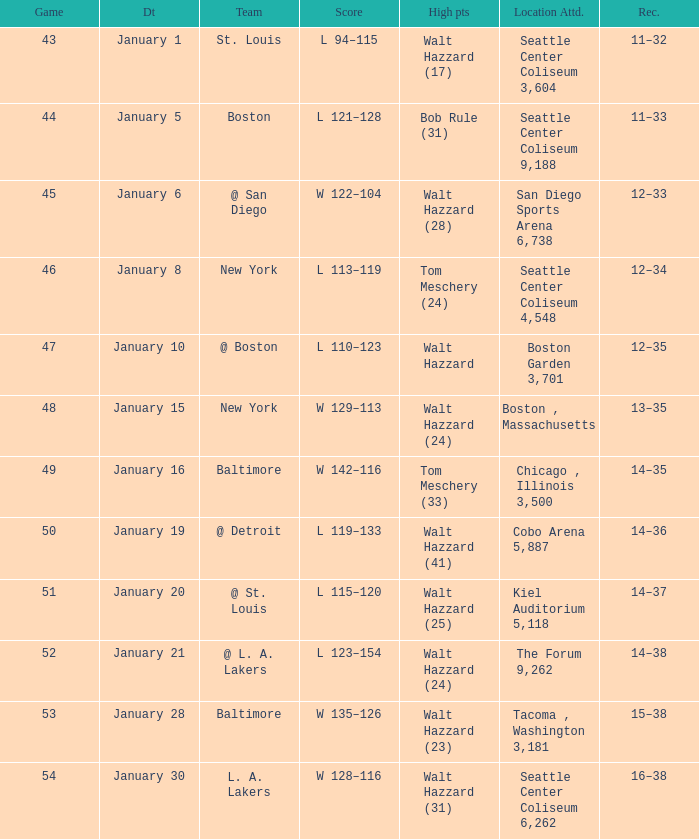What is the record for the St. Louis team? 11–32. 